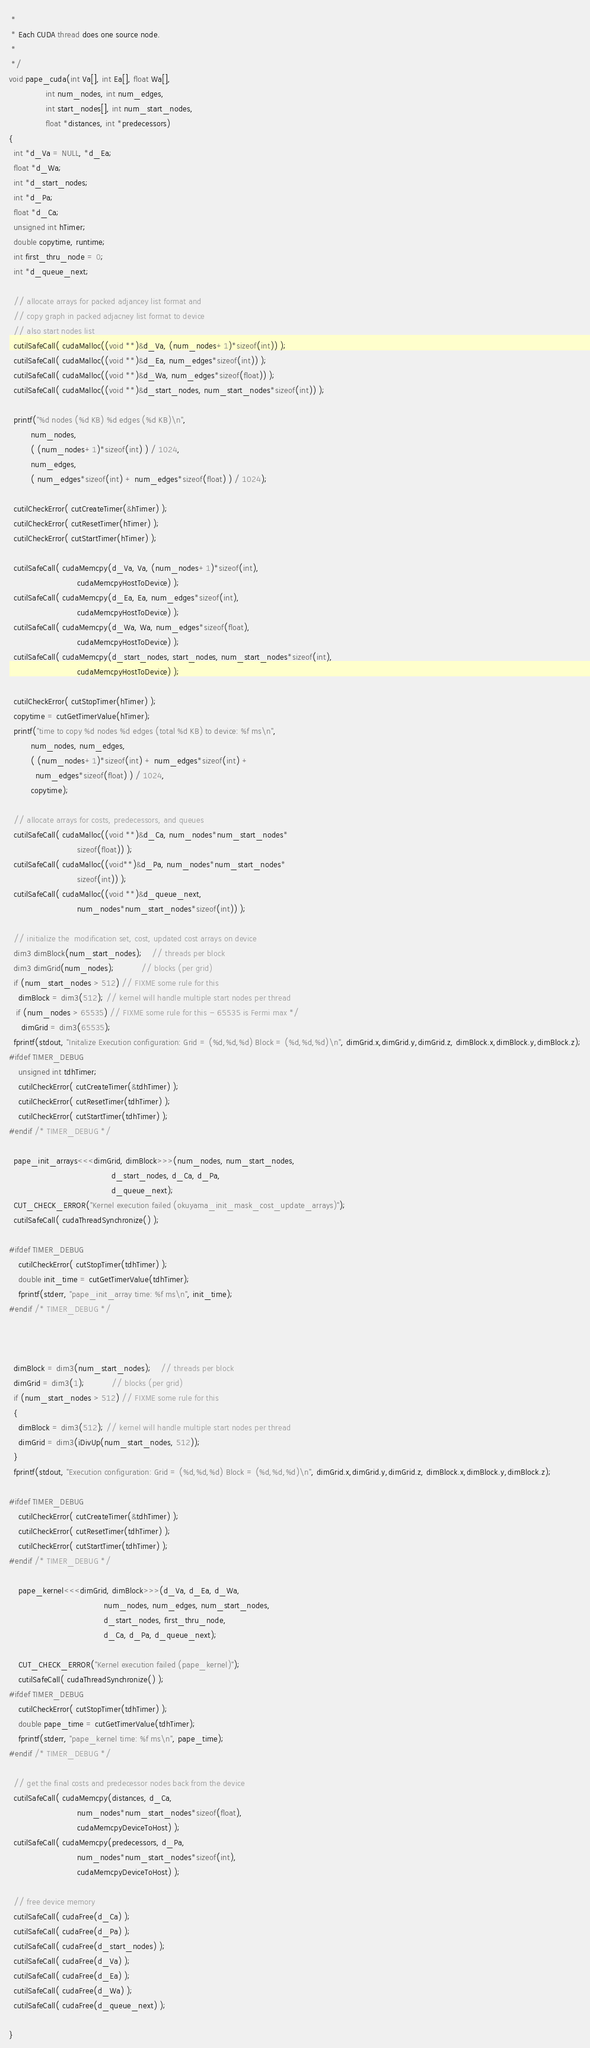Convert code to text. <code><loc_0><loc_0><loc_500><loc_500><_Cuda_> *
 * Each CUDA thread does one source node.
 *
 */
void pape_cuda(int Va[], int Ea[], float Wa[], 
               int num_nodes, int num_edges,
               int start_nodes[], int num_start_nodes,
               float *distances, int *predecessors)
{
  int *d_Va = NULL, *d_Ea;
  float *d_Wa;
  int *d_start_nodes;
  int *d_Pa;
  float *d_Ca;
  unsigned int hTimer;
  double copytime, runtime;
  int first_thru_node = 0;
  int *d_queue_next;

  // allocate arrays for packed adjancey list format and 
  // copy graph in packed adjacney list format to device
  // also start nodes list
  cutilSafeCall( cudaMalloc((void **)&d_Va, (num_nodes+1)*sizeof(int)) );
  cutilSafeCall( cudaMalloc((void **)&d_Ea, num_edges*sizeof(int)) );
  cutilSafeCall( cudaMalloc((void **)&d_Wa, num_edges*sizeof(float)) );
  cutilSafeCall( cudaMalloc((void **)&d_start_nodes, num_start_nodes*sizeof(int)) );

  printf("%d nodes (%d KB) %d edges (%d KB)\n",
         num_nodes, 
         ( (num_nodes+1)*sizeof(int) ) / 1024,
         num_edges,
         ( num_edges*sizeof(int) + num_edges*sizeof(float) ) / 1024);

  cutilCheckError( cutCreateTimer(&hTimer) );
  cutilCheckError( cutResetTimer(hTimer) );
  cutilCheckError( cutStartTimer(hTimer) );

  cutilSafeCall( cudaMemcpy(d_Va, Va, (num_nodes+1)*sizeof(int),
                            cudaMemcpyHostToDevice) );
  cutilSafeCall( cudaMemcpy(d_Ea, Ea, num_edges*sizeof(int),
                            cudaMemcpyHostToDevice) );
  cutilSafeCall( cudaMemcpy(d_Wa, Wa, num_edges*sizeof(float),
                            cudaMemcpyHostToDevice) );
  cutilSafeCall( cudaMemcpy(d_start_nodes, start_nodes, num_start_nodes*sizeof(int),
                            cudaMemcpyHostToDevice) );
  
  cutilCheckError( cutStopTimer(hTimer) );
  copytime = cutGetTimerValue(hTimer);
  printf("time to copy %d nodes %d edges (total %d KB) to device: %f ms\n",
         num_nodes, num_edges,
         ( (num_nodes+1)*sizeof(int) + num_edges*sizeof(int) +
           num_edges*sizeof(float) ) / 1024,
         copytime);

  // allocate arrays for costs, predecessors, and queues
  cutilSafeCall( cudaMalloc((void **)&d_Ca, num_nodes*num_start_nodes*
                            sizeof(float)) );
  cutilSafeCall( cudaMalloc((void**)&d_Pa, num_nodes*num_start_nodes*
                            sizeof(int)) );
  cutilSafeCall( cudaMalloc((void **)&d_queue_next, 
                            num_nodes*num_start_nodes*sizeof(int)) );

  // initialize the  modification set, cost, updated cost arrays on device
  dim3 dimBlock(num_start_nodes);    // threads per block
  dim3 dimGrid(num_nodes);           // blocks (per grid)
  if (num_start_nodes > 512) // FIXME some rule for this
    dimBlock = dim3(512); // kernel will handle multiple start nodes per thread
   if (num_nodes > 65535) // FIXME some rule for this - 65535 is Fermi max */
     dimGrid = dim3(65535);
  fprintf(stdout, "Initalize Execution configuration: Grid = (%d,%d,%d) Block = (%d,%d,%d)\n", dimGrid.x,dimGrid.y,dimGrid.z, dimBlock.x,dimBlock.y,dimBlock.z);
#ifdef TIMER_DEBUG
    unsigned int tdhTimer;
    cutilCheckError( cutCreateTimer(&tdhTimer) );
    cutilCheckError( cutResetTimer(tdhTimer) );
    cutilCheckError( cutStartTimer(tdhTimer) );
#endif /* TIMER_DEBUG */

  pape_init_arrays<<<dimGrid, dimBlock>>>(num_nodes, num_start_nodes,
                                          d_start_nodes, d_Ca, d_Pa,
                                          d_queue_next);
  CUT_CHECK_ERROR("Kernel execution failed (okuyama_init_mask_cost_update_arrays)");
  cutilSafeCall( cudaThreadSynchronize() );

#ifdef TIMER_DEBUG
    cutilCheckError( cutStopTimer(tdhTimer) );
    double init_time = cutGetTimerValue(tdhTimer);
    fprintf(stderr, "pape_init_array time: %f ms\n", init_time);
#endif /* TIMER_DEBUG */



  dimBlock = dim3(num_start_nodes);    // threads per block
  dimGrid = dim3(1);           // blocks (per grid)
  if (num_start_nodes > 512) // FIXME some rule for this
  {
    dimBlock = dim3(512); // kernel will handle multiple start nodes per thread
    dimGrid = dim3(iDivUp(num_start_nodes, 512));
  }
  fprintf(stdout, "Execution configuration: Grid = (%d,%d,%d) Block = (%d,%d,%d)\n", dimGrid.x,dimGrid.y,dimGrid.z, dimBlock.x,dimBlock.y,dimBlock.z);

#ifdef TIMER_DEBUG
    cutilCheckError( cutCreateTimer(&tdhTimer) );
    cutilCheckError( cutResetTimer(tdhTimer) );
    cutilCheckError( cutStartTimer(tdhTimer) );
#endif /* TIMER_DEBUG */
    
    pape_kernel<<<dimGrid, dimBlock>>>(d_Va, d_Ea, d_Wa,
                                       num_nodes, num_edges, num_start_nodes,
                                       d_start_nodes, first_thru_node,
                                       d_Ca, d_Pa, d_queue_next);

    CUT_CHECK_ERROR("Kernel execution failed (pape_kernel)");
    cutilSafeCall( cudaThreadSynchronize() );
#ifdef TIMER_DEBUG
    cutilCheckError( cutStopTimer(tdhTimer) );
    double pape_time = cutGetTimerValue(tdhTimer);
    fprintf(stderr, "pape_kernel time: %f ms\n", pape_time);
#endif /* TIMER_DEBUG */

  // get the final costs and predecessor nodes back from the device
  cutilSafeCall( cudaMemcpy(distances, d_Ca, 
                            num_nodes*num_start_nodes*sizeof(float),
                            cudaMemcpyDeviceToHost) );
  cutilSafeCall( cudaMemcpy(predecessors, d_Pa,
                            num_nodes*num_start_nodes*sizeof(int),
                            cudaMemcpyDeviceToHost) );

  // free device memory
  cutilSafeCall( cudaFree(d_Ca) );
  cutilSafeCall( cudaFree(d_Pa) );
  cutilSafeCall( cudaFree(d_start_nodes) );
  cutilSafeCall( cudaFree(d_Va) );
  cutilSafeCall( cudaFree(d_Ea) );
  cutilSafeCall( cudaFree(d_Wa) );
  cutilSafeCall( cudaFree(d_queue_next) );

}
</code> 